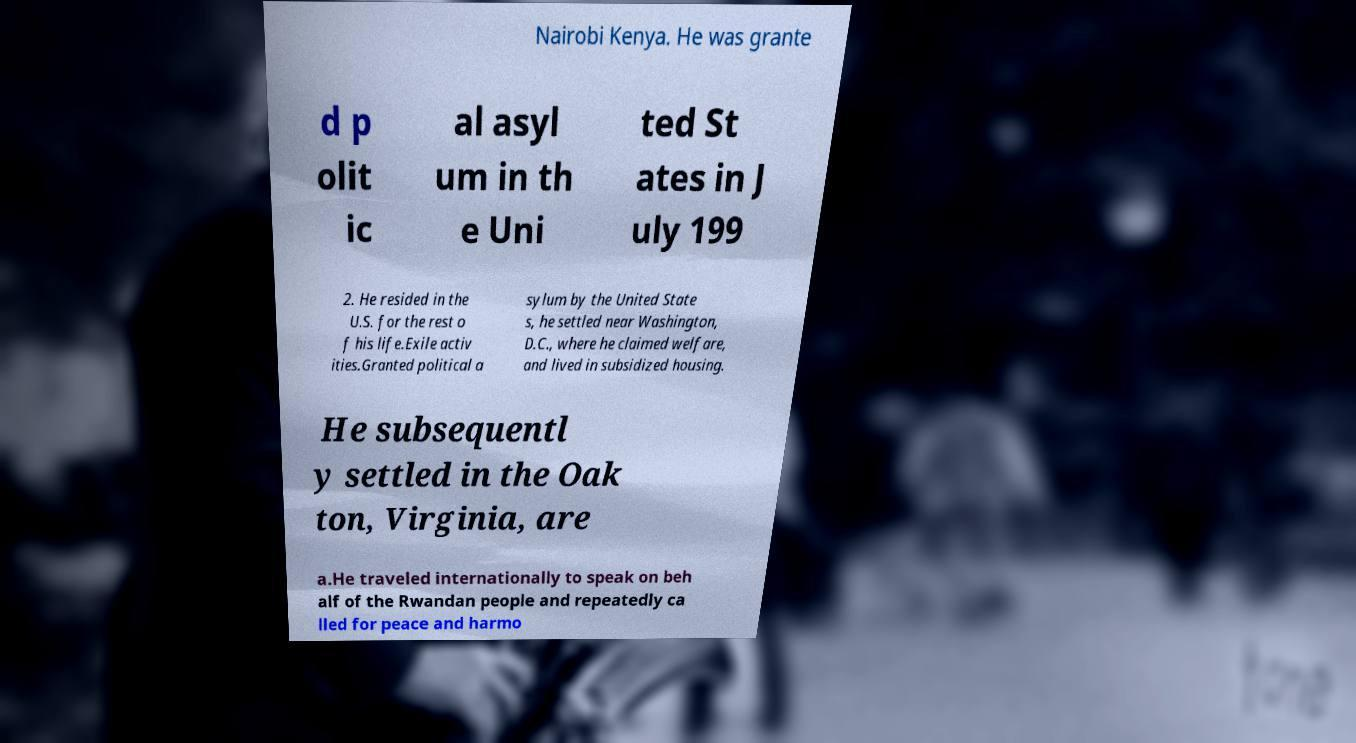Can you read and provide the text displayed in the image?This photo seems to have some interesting text. Can you extract and type it out for me? Nairobi Kenya. He was grante d p olit ic al asyl um in th e Uni ted St ates in J uly 199 2. He resided in the U.S. for the rest o f his life.Exile activ ities.Granted political a sylum by the United State s, he settled near Washington, D.C., where he claimed welfare, and lived in subsidized housing. He subsequentl y settled in the Oak ton, Virginia, are a.He traveled internationally to speak on beh alf of the Rwandan people and repeatedly ca lled for peace and harmo 